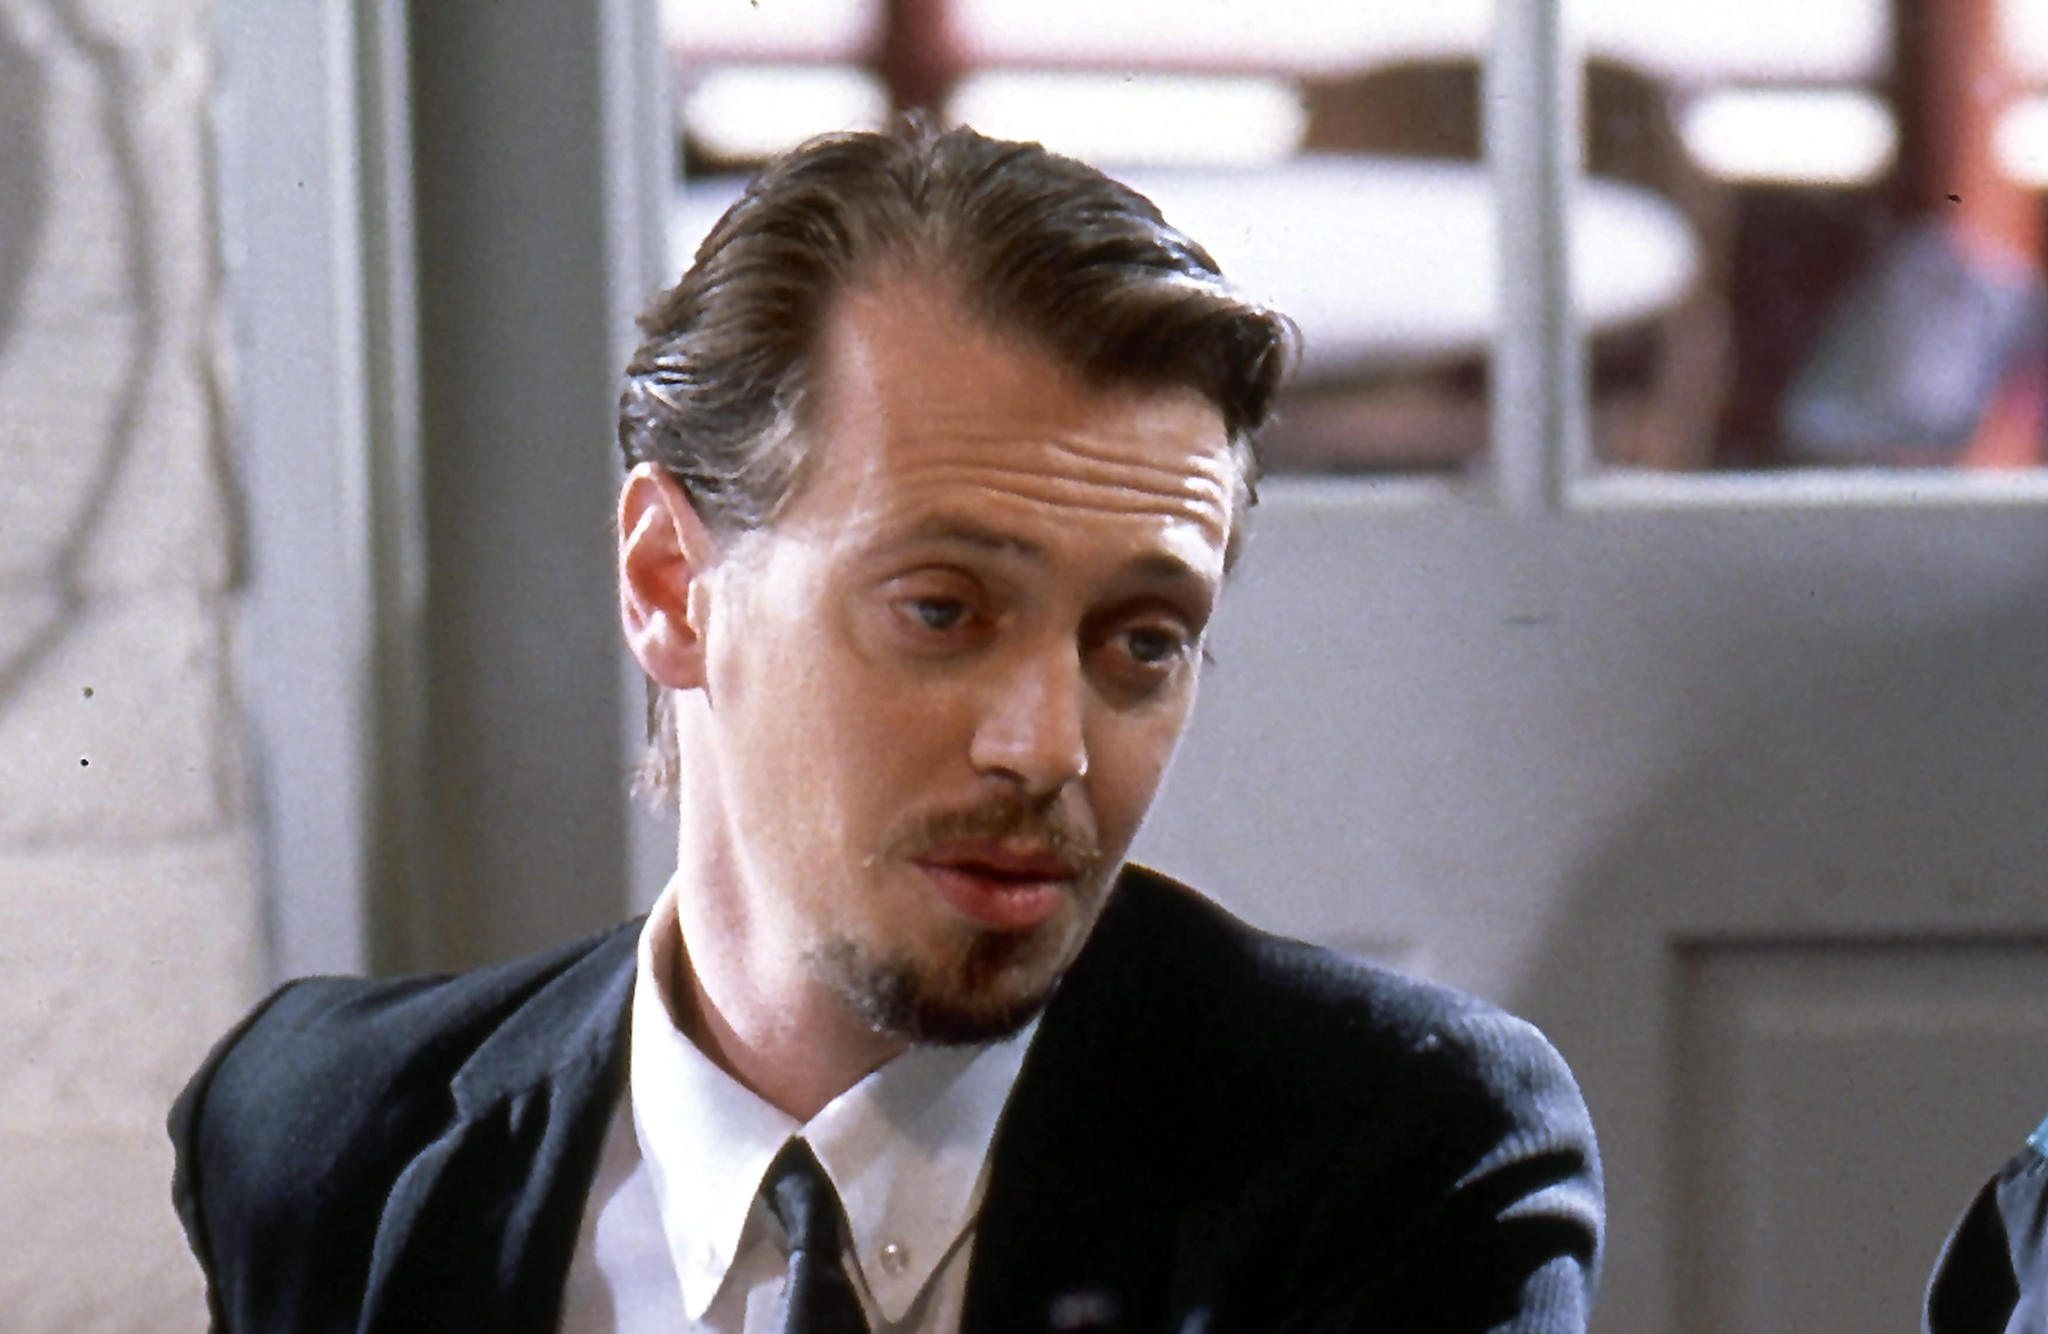Imagine this character is meeting someone important. Write a detailed account of his thoughts and actions. Mr. Pink, his gaze unwavering, awaited the arrival of his contact at the secluded corner table of the dimly lit café. Each movement was calculated, precise, maintaining an air of calmness that belied the pounding of his heart. As he straightened his tie, he couldn’t help but replay the series of events that led him here. Trust was a commodity he couldn’t afford, yet this meeting held the promise of information pivotal to his survival. He'd done his homework, knew who he was dealing with, yet the unpredictability gnawed at him. His fingers drummed the surface of the table, a silent rhythm keeping pace with his thoughts. The door creaked open, and in walked a figure that commanded the room's attention. Mr. Pink's eyes narrowed, calculating every possible outcome as the figure approached. 'Stay sharp, stay in control,' he reminded himself. The stakes were high, and he was ready to face whatever unfolded, his mind a battlefield of strategy and anticipation. 